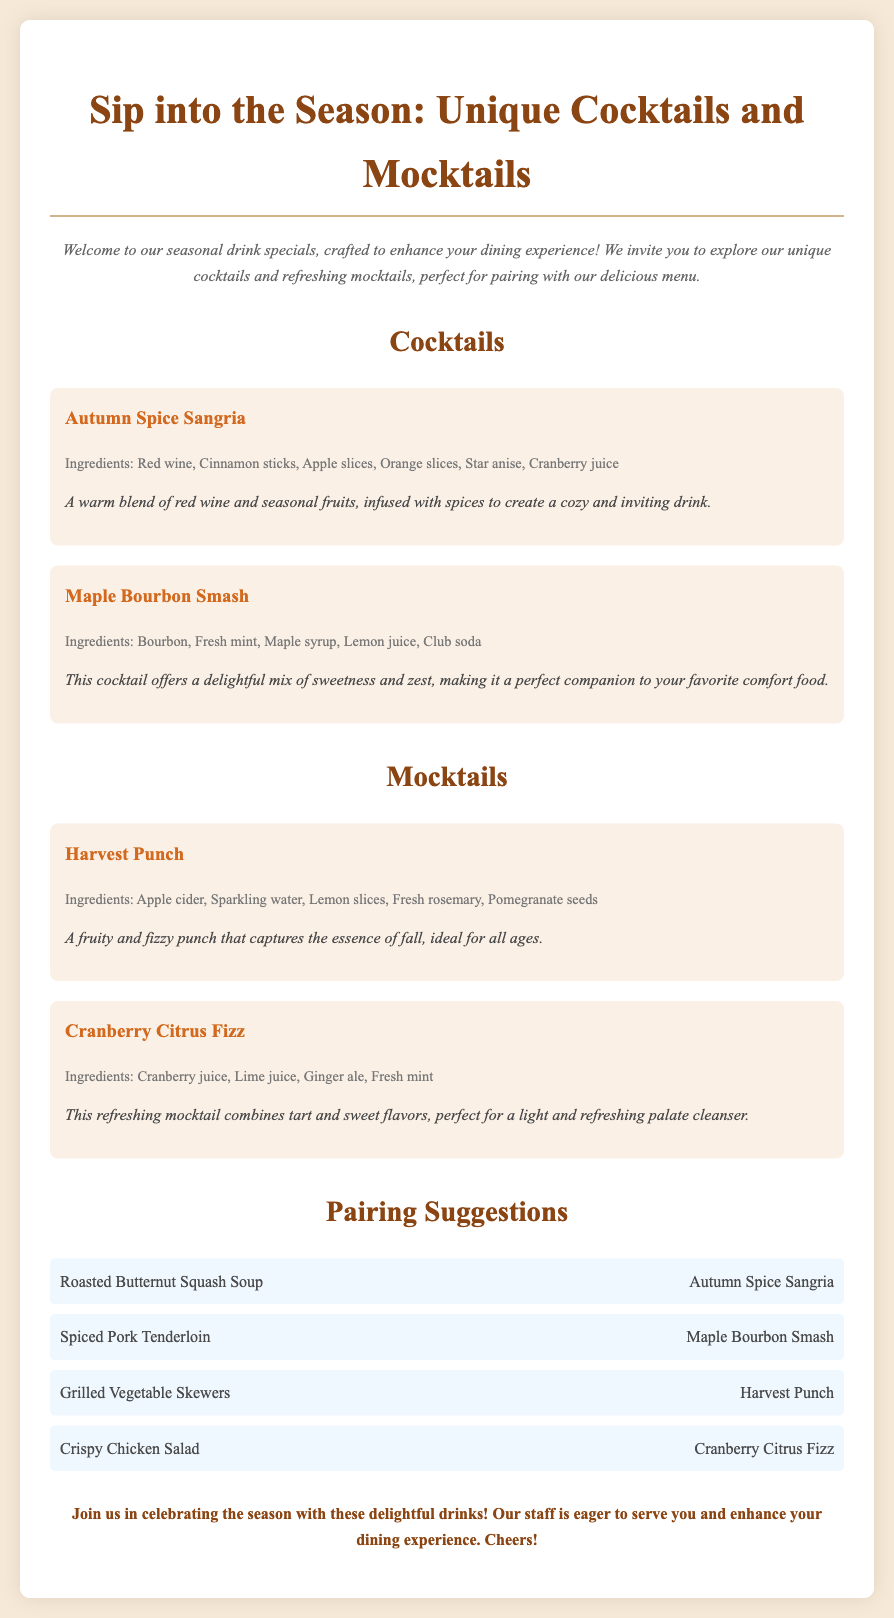What is the title of the document? The title of the document is presented in a large font at the top of the flyer.
Answer: Sip into the Season: Unique Cocktails and Mocktails How many cocktails are featured? The document lists two distinct cocktails under the Cocktails section.
Answer: 2 What is one ingredient in the Autumn Spice Sangria? The ingredients for the Autumn Spice Sangria are listed below its name.
Answer: Red wine What mocktail is paired with Grilled Vegetable Skewers? The pairing suggestions list includes what mocktail goes with Grilled Vegetable Skewers.
Answer: Harvest Punch What type of drink is the Cranberry Citrus Fizz? This drink is categorized under the Mocktails section of the document.
Answer: Mocktail Which cocktail features maple syrup? The description for the Maple Bourbon Smash indicates its ingredients, including maple syrup.
Answer: Maple Bourbon Smash What is the description of the Harvest Punch? The description can be found after the name of the Harvest Punch.
Answer: A fruity and fizzy punch that captures the essence of fall, ideal for all ages What color is the background of the document? The background color is mentioned in the styling section and can be observed in the visualization of the flyer.
Answer: #f7e9d7 